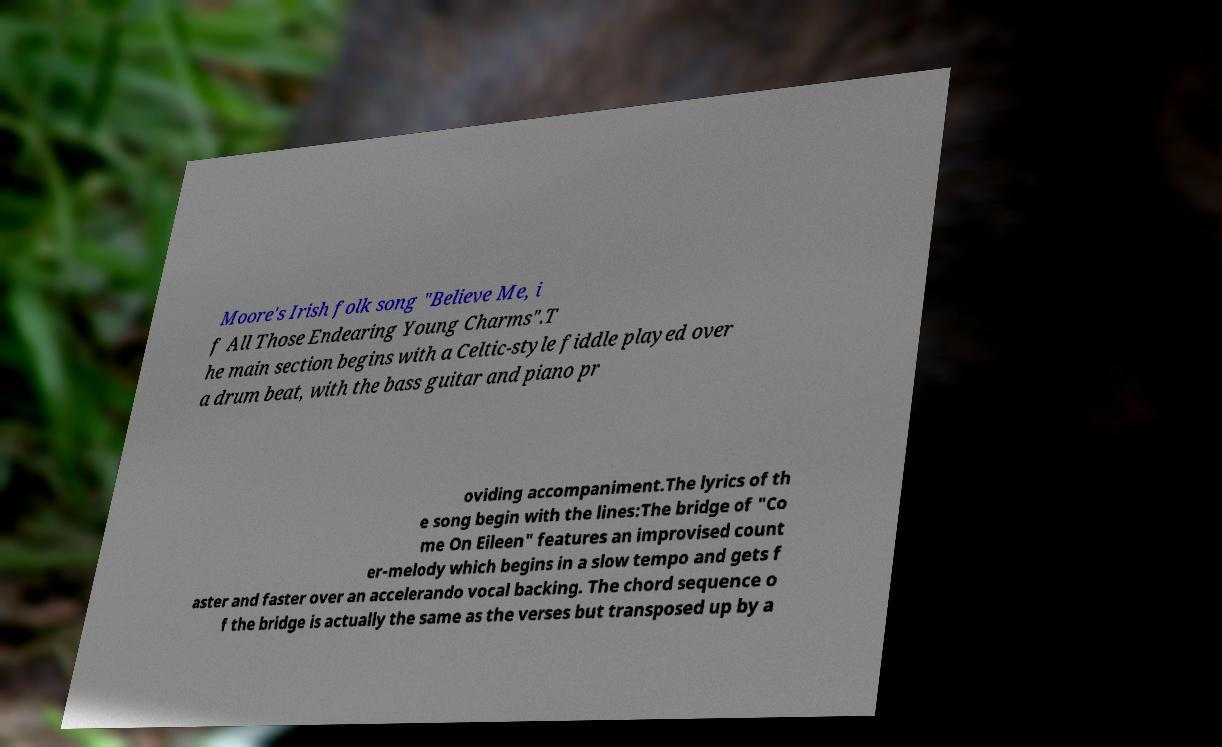Can you accurately transcribe the text from the provided image for me? Moore's Irish folk song "Believe Me, i f All Those Endearing Young Charms".T he main section begins with a Celtic-style fiddle played over a drum beat, with the bass guitar and piano pr oviding accompaniment.The lyrics of th e song begin with the lines:The bridge of "Co me On Eileen" features an improvised count er-melody which begins in a slow tempo and gets f aster and faster over an accelerando vocal backing. The chord sequence o f the bridge is actually the same as the verses but transposed up by a 